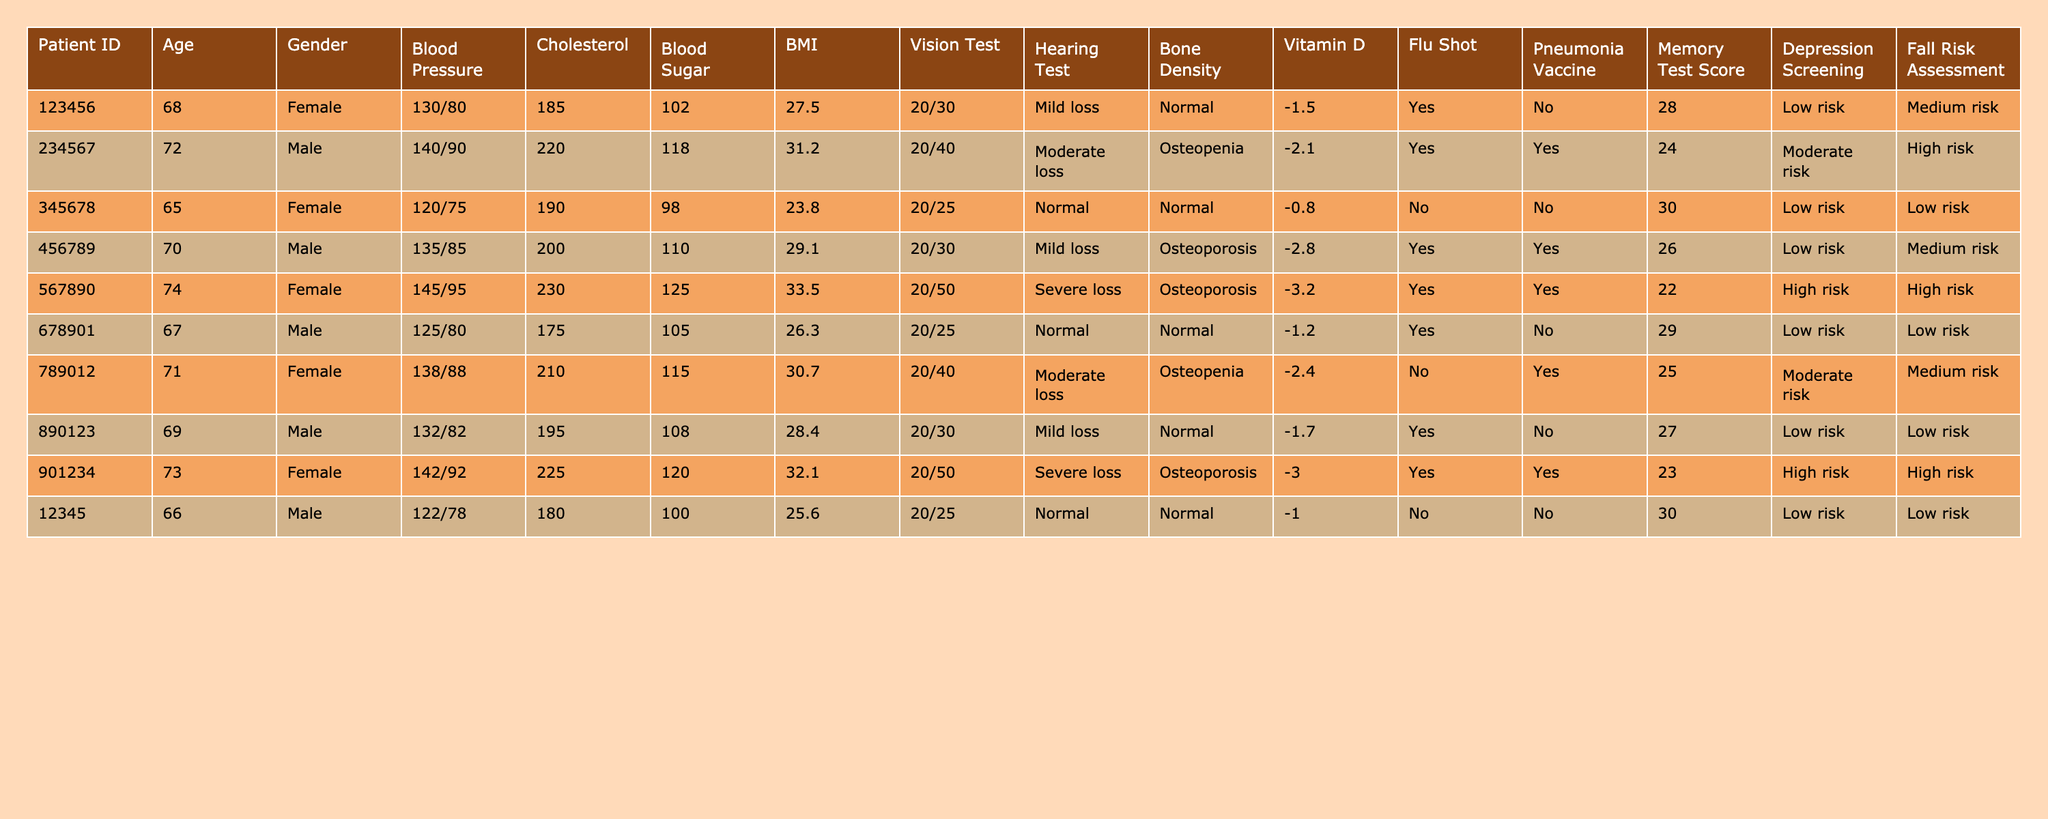What is the blood pressure of the oldest patient? The oldest patient is identified by age, which is 74. Looking at that row in the table, the blood pressure is recorded as 145/95.
Answer: 145/95 How many patients received the Flu Shot? Looking through the table, I can see that 6 out of 10 patients have indicated "Yes" for having received the Flu Shot.
Answer: 6 What is the average BMI of the patients? To find the average BMI, I add all the BMI values (27.5 + 31.2 + 23.8 + 29.1 + 33.5 + 26.3 + 30.7 + 28.4 + 32.1 + 25.6) which equals  2.01). Dividing this sum by the number of patients (10), the average BMI is 28.11.
Answer: 28.11 Is there any female patient with a medium risk in the Fall Risk Assessment? Looking through all the female patients, I find that both the 68-year-old and the 74-year-old females have a medium risk. Therefore, there are female patients with medium risk.
Answer: Yes Which patient has the highest Cholesterol level, and what is that level? Scanning through the Cholesterol data, the patient with ID 567890 has the highest Cholesterol level listed as 230.
Answer: 230 What is the difference in Memory Test Scores between the patients with the highest and lowest scores? The highest Memory Test Score is 30 (from the patient ID 345678), and the lowest is 22 (from the patient ID 567890). The difference is 30 - 22 = 8.
Answer: 8 Are there any males with a hearing test rating of "Severe loss"? Examining the gender and hearing test ratings, I find that two males, aged 70 and 74, both have "Severe loss" in their hearing tests.
Answer: Yes What percentage of patients are at high risk for depression? There are 2 patients at high risk for depression out of 10 patients total. To find the percentage, I calculate (2/10)*100 = 20%.
Answer: 20% Which patient has the lowest Blood Sugar reading, and what is that reading? Reviewing the Blood Sugar values, the patient with ID 345678 has the lowest reading at 98.
Answer: 98 How many patients have Osteoporosis and are female? I check the gender and Bone Density data, and I find that 2 female patients (the 74-year-old and the 73-year-old) have Osteoporosis.
Answer: 2 